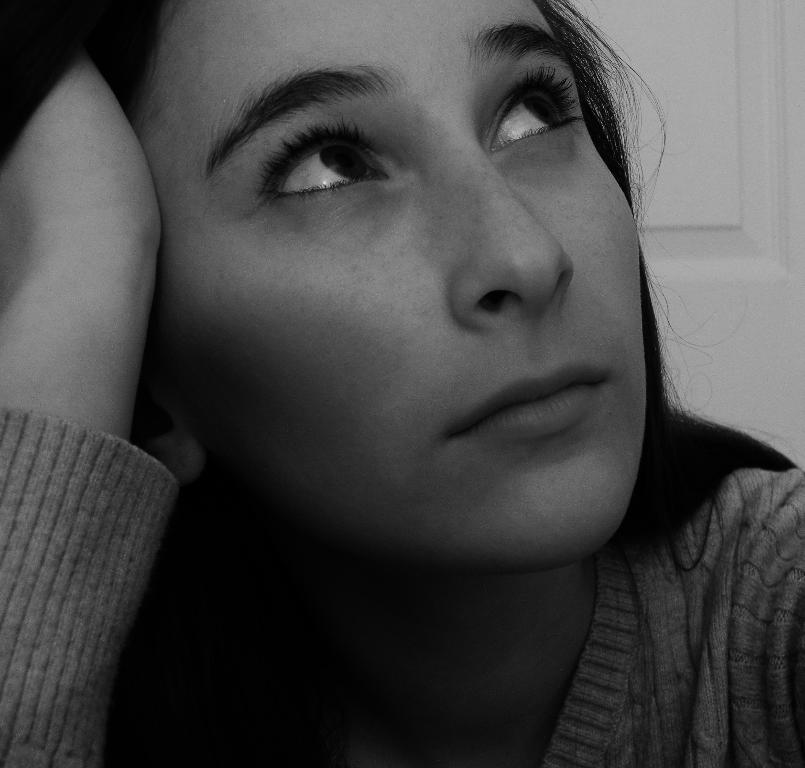Who is the main subject in the image? There is a lady in the image. What can be seen in the background of the image? There is a door in the background of the image. What type of swing does the owner use in the image? There is no swing present in the image, and no owner is mentioned. 